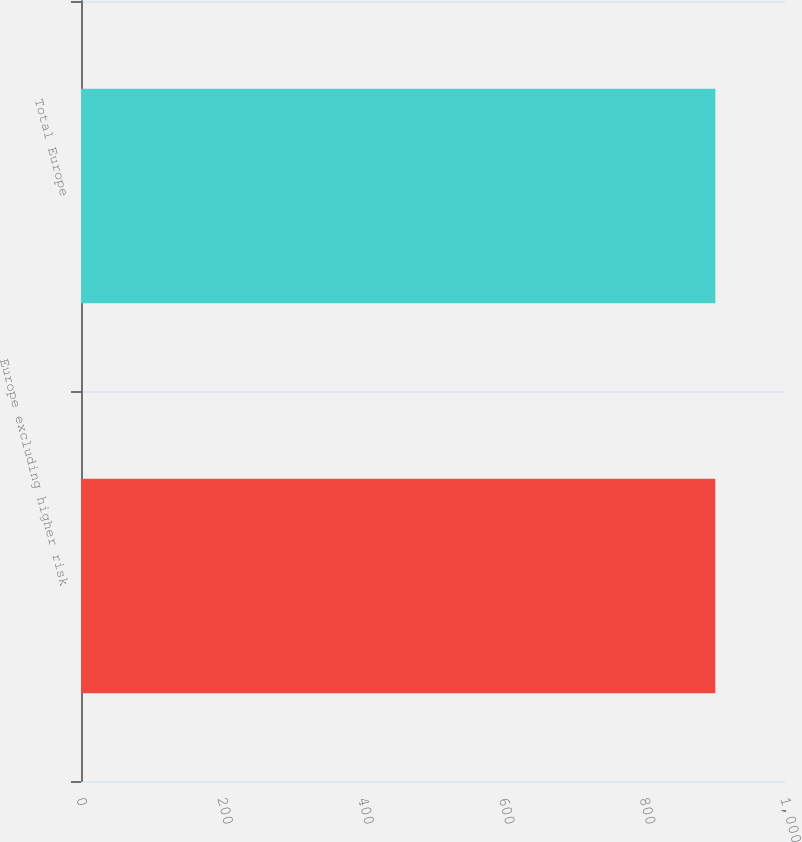Convert chart to OTSL. <chart><loc_0><loc_0><loc_500><loc_500><bar_chart><fcel>Europe excluding higher risk<fcel>Total Europe<nl><fcel>901<fcel>901.1<nl></chart> 